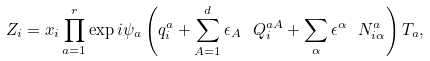Convert formula to latex. <formula><loc_0><loc_0><loc_500><loc_500>Z _ { i } = x _ { i } \prod _ { a = 1 } ^ { r } \exp i \psi _ { a } \left ( q _ { i } ^ { a } + \sum _ { A = 1 } ^ { d } \epsilon _ { A } \text { } Q _ { i } ^ { a A } + \sum _ { \alpha } \epsilon ^ { \alpha } \text { } N _ { i \alpha } ^ { a } \right ) T _ { a } ,</formula> 